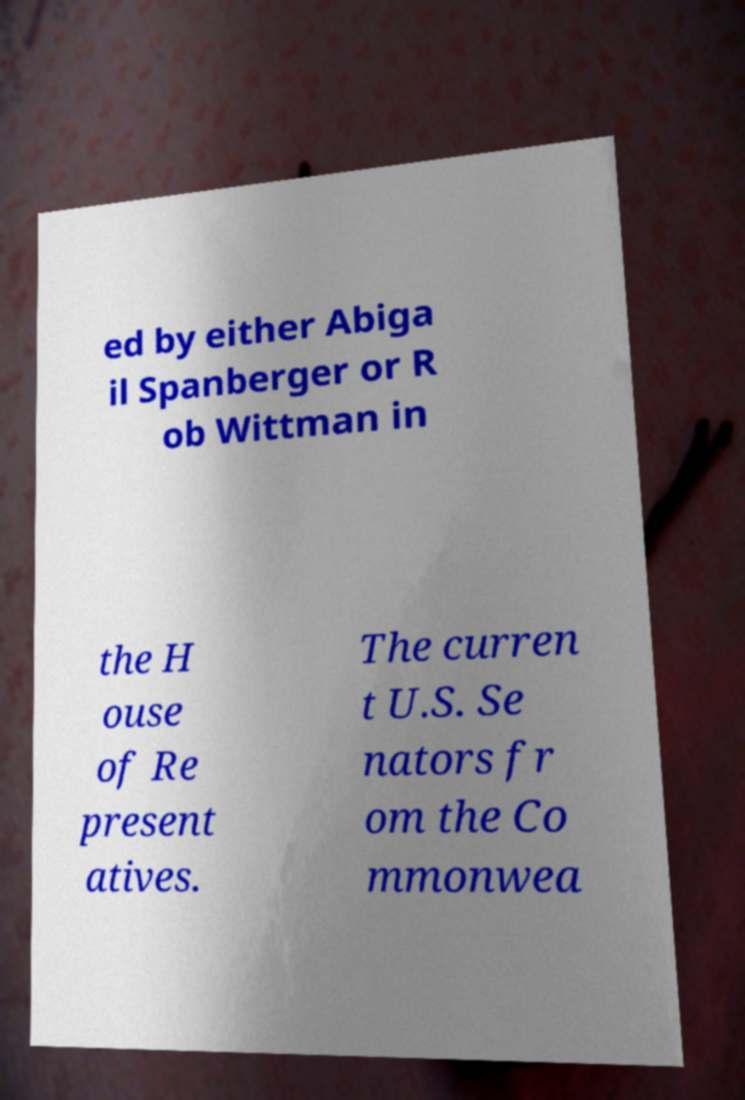What messages or text are displayed in this image? I need them in a readable, typed format. ed by either Abiga il Spanberger or R ob Wittman in the H ouse of Re present atives. The curren t U.S. Se nators fr om the Co mmonwea 